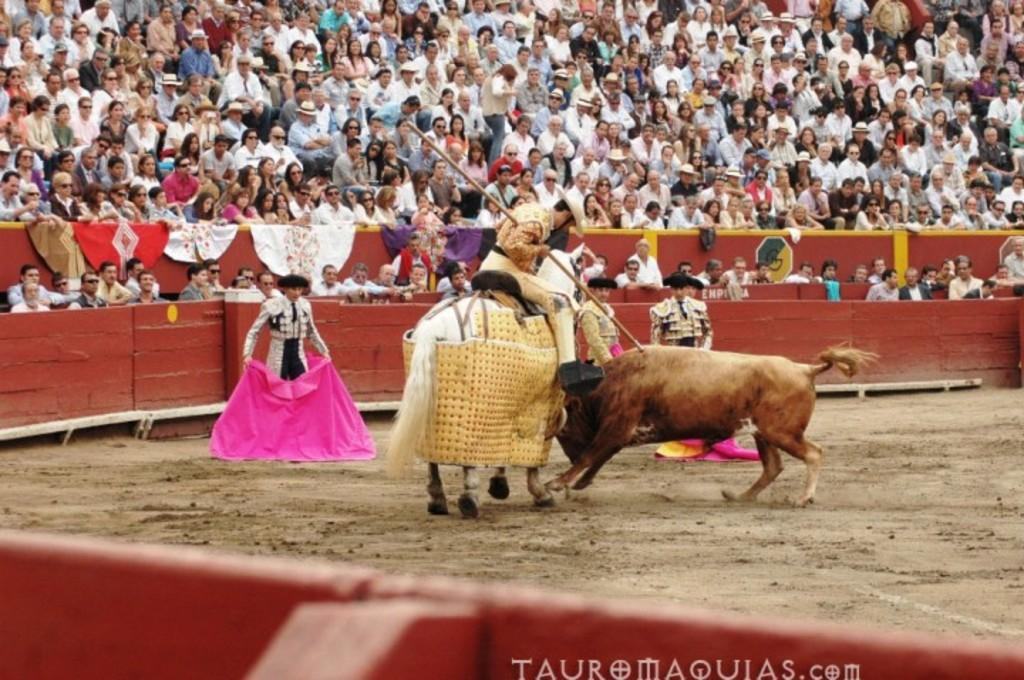What is happening in the image? There is a bullfight in the image. What colors are the bulls in the image? The bulls are in white and brown colors. Can you describe the people in the background? There is a group of people sitting in the background. What is the color of the wall in the background? The wall in the background is brown in color. What type of star can be seen in the image? There is no star visible in the image; it features a bullfight with bulls and people in the background. Can you tell me where the toy store is located in the image? There is no toy store present in the image; it depicts a bullfight with bulls and people in the background. 